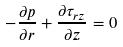<formula> <loc_0><loc_0><loc_500><loc_500>- \frac { \partial p } { \partial r } + \frac { \partial \tau _ { r z } } { \partial z } = 0</formula> 